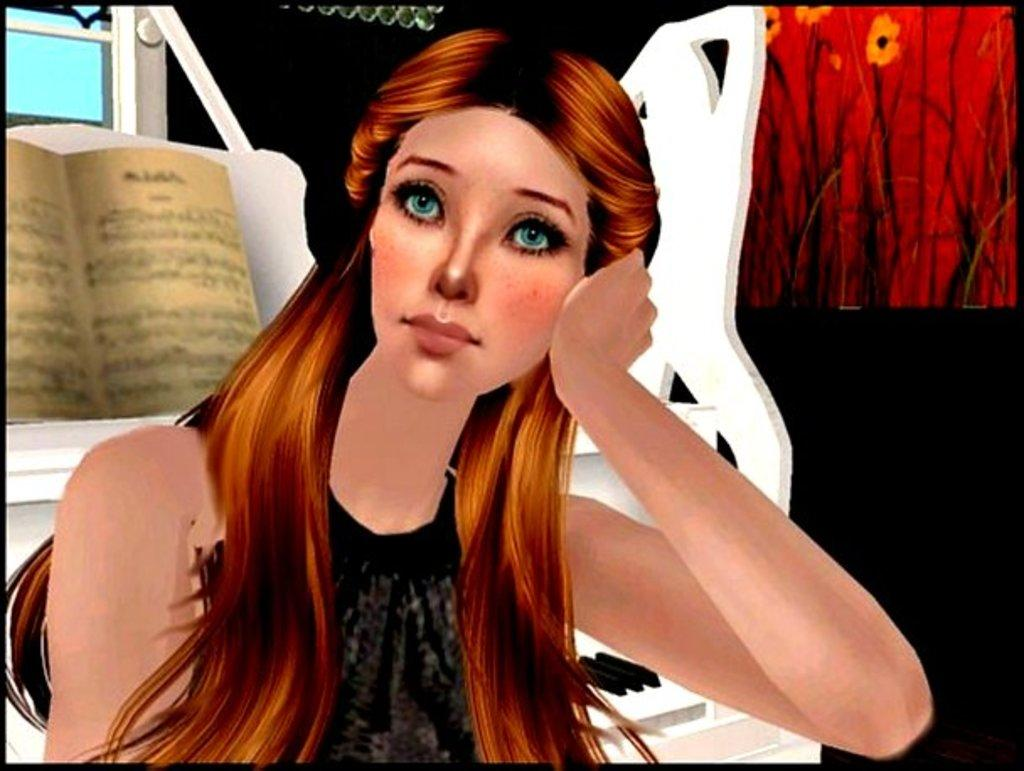What is depicted in the painting in the image? There is a painting of a girl in the image. What musical instrument can be seen in the image? There is a piano in the image. What object related to reading is present in the image? There is a book in the image. How many stamps are on the girl's forehead in the painting? There are no stamps present on the girl's forehead in the painting; it is a painting of a girl without any stamps. What type of snakes are coiled around the piano in the image? There are no snakes present around the piano in the image; it is a piano without any snakes. 